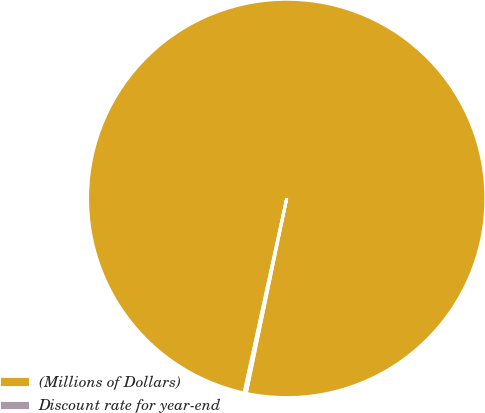<chart> <loc_0><loc_0><loc_500><loc_500><pie_chart><fcel>(Millions of Dollars)<fcel>Discount rate for year-end<nl><fcel>99.82%<fcel>0.18%<nl></chart> 